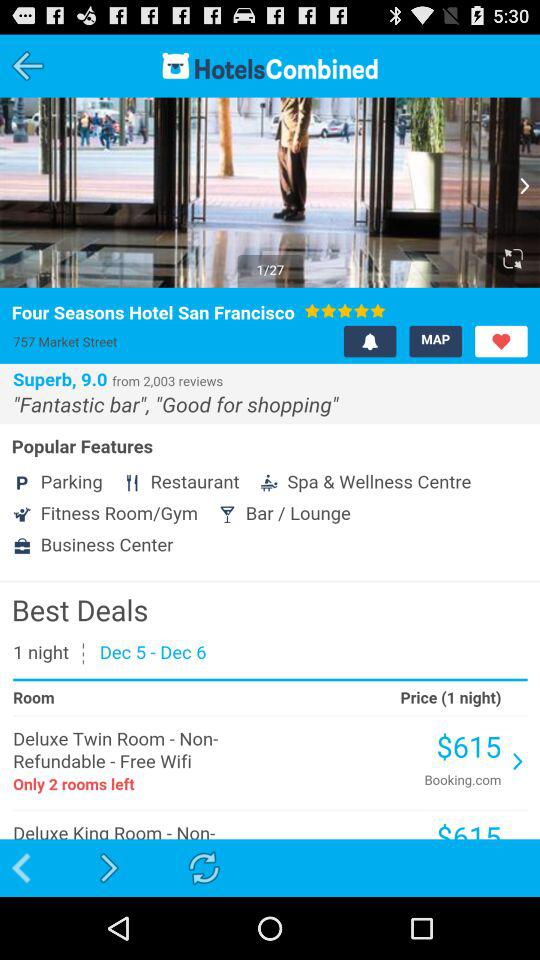How many rooms are left? There are 2 rooms left. 